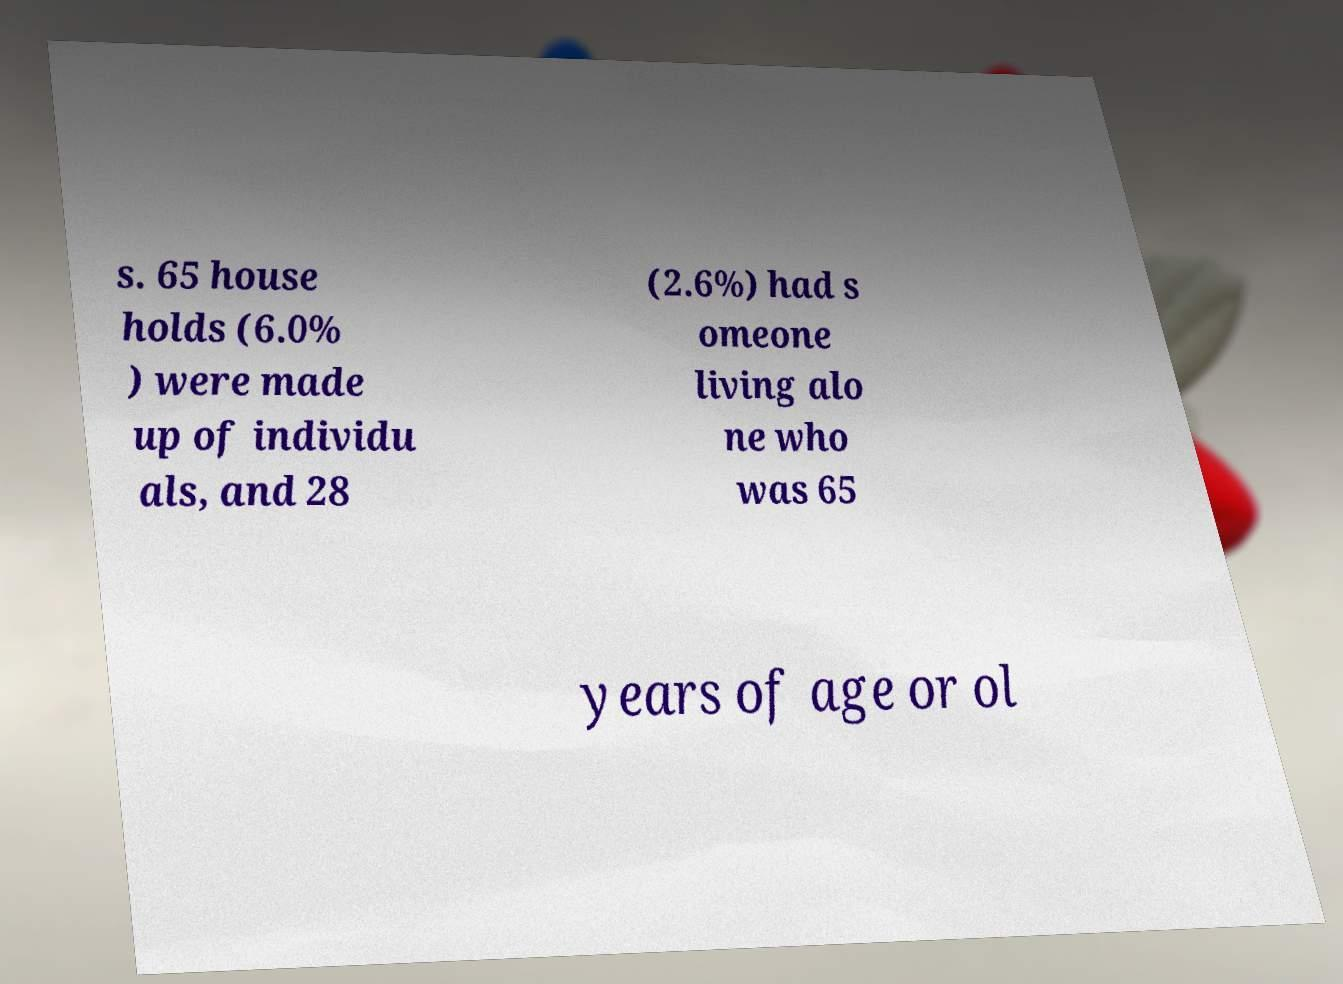For documentation purposes, I need the text within this image transcribed. Could you provide that? s. 65 house holds (6.0% ) were made up of individu als, and 28 (2.6%) had s omeone living alo ne who was 65 years of age or ol 